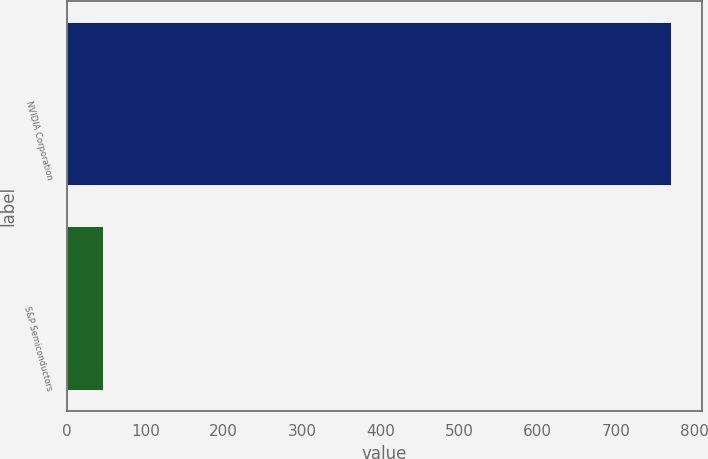Convert chart to OTSL. <chart><loc_0><loc_0><loc_500><loc_500><bar_chart><fcel>NVIDIA Corporation<fcel>S&P Semiconductors<nl><fcel>771<fcel>45.49<nl></chart> 